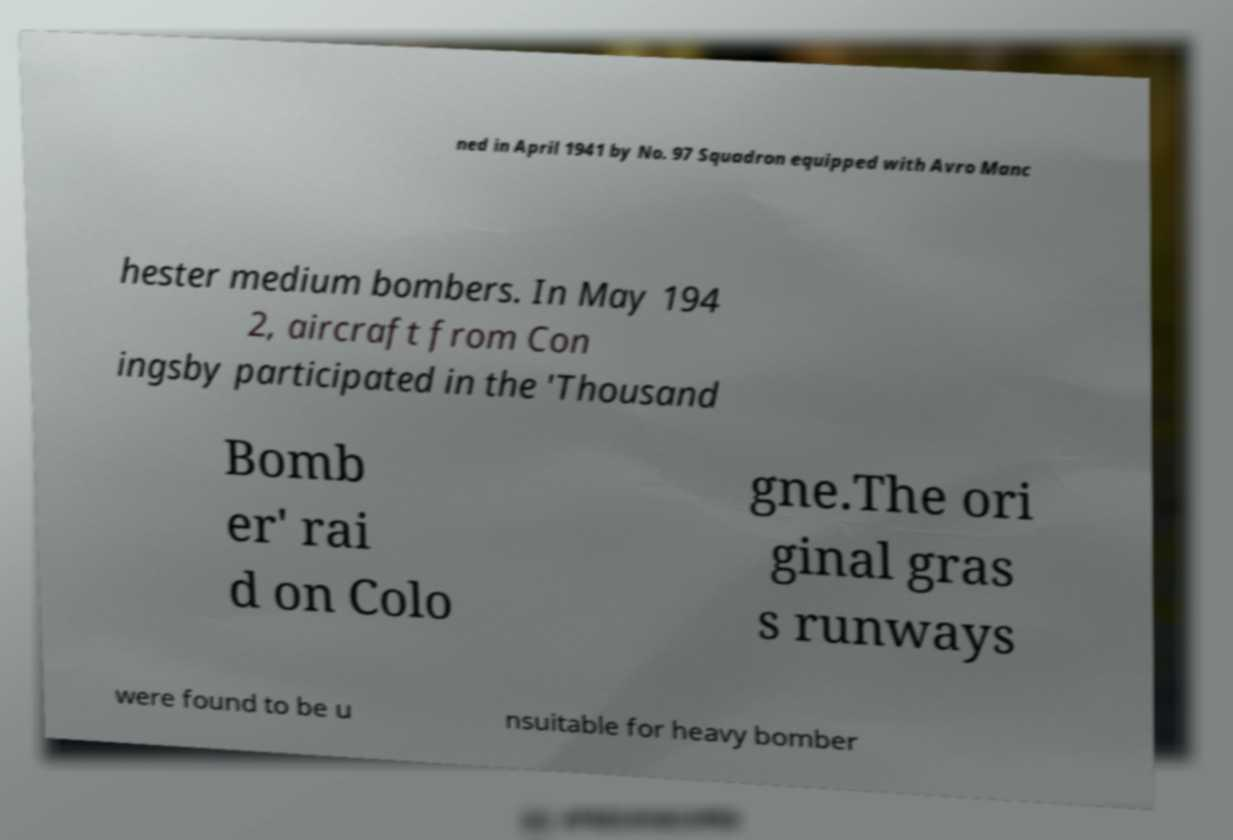For documentation purposes, I need the text within this image transcribed. Could you provide that? ned in April 1941 by No. 97 Squadron equipped with Avro Manc hester medium bombers. In May 194 2, aircraft from Con ingsby participated in the 'Thousand Bomb er' rai d on Colo gne.The ori ginal gras s runways were found to be u nsuitable for heavy bomber 